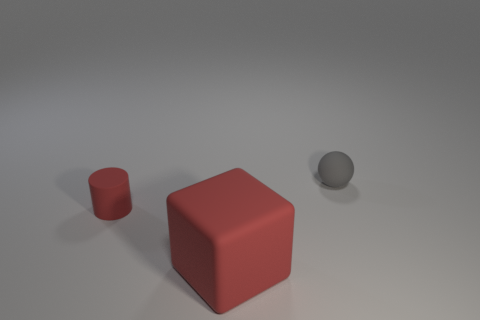What is the shape of the tiny thing that is the same color as the big thing?
Your answer should be compact. Cylinder. How many brown objects are either large things or small rubber balls?
Give a very brief answer. 0. How big is the red rubber cube?
Ensure brevity in your answer.  Large. Is the number of things that are to the left of the rubber ball greater than the number of big red matte things?
Make the answer very short. Yes. There is a big rubber block; what number of cylinders are in front of it?
Your response must be concise. 0. Is there a green object of the same size as the gray ball?
Ensure brevity in your answer.  No. Is the size of the red matte object right of the small cylinder the same as the rubber object behind the cylinder?
Provide a short and direct response. No. Are there the same number of red rubber cylinders that are left of the red cube and small red things?
Make the answer very short. Yes. There is a rubber ball; does it have the same size as the red matte object that is behind the red matte block?
Your answer should be compact. Yes. What number of small gray things have the same material as the ball?
Keep it short and to the point. 0. 